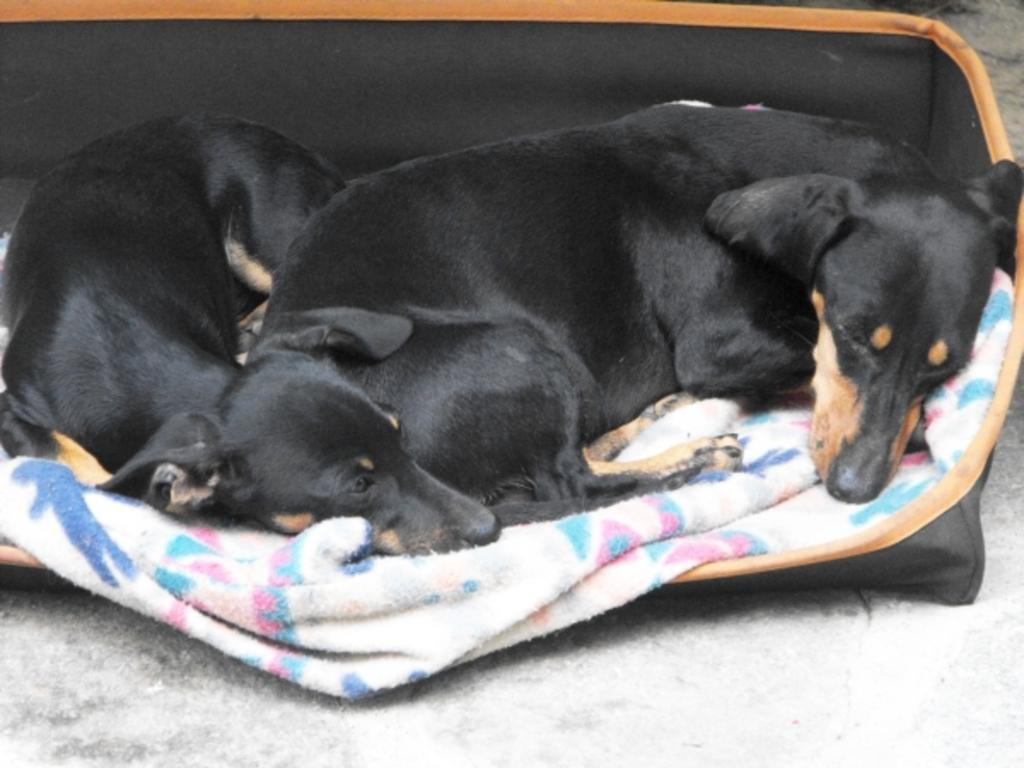What type of animals are present in the image? There are dogs in the image. What object is in a bag in the image? There is a cloth in a bag in the image. What surface can be seen at the bottom of the image? There is a floor visible at the bottom of the image. How many pigs are visible in the image? There are no pigs present in the image; it features dogs and a cloth in a bag. What type of ice can be seen melting on the floor in the image? There is no ice present in the image; it only features dogs, a cloth in a bag, and a floor. 